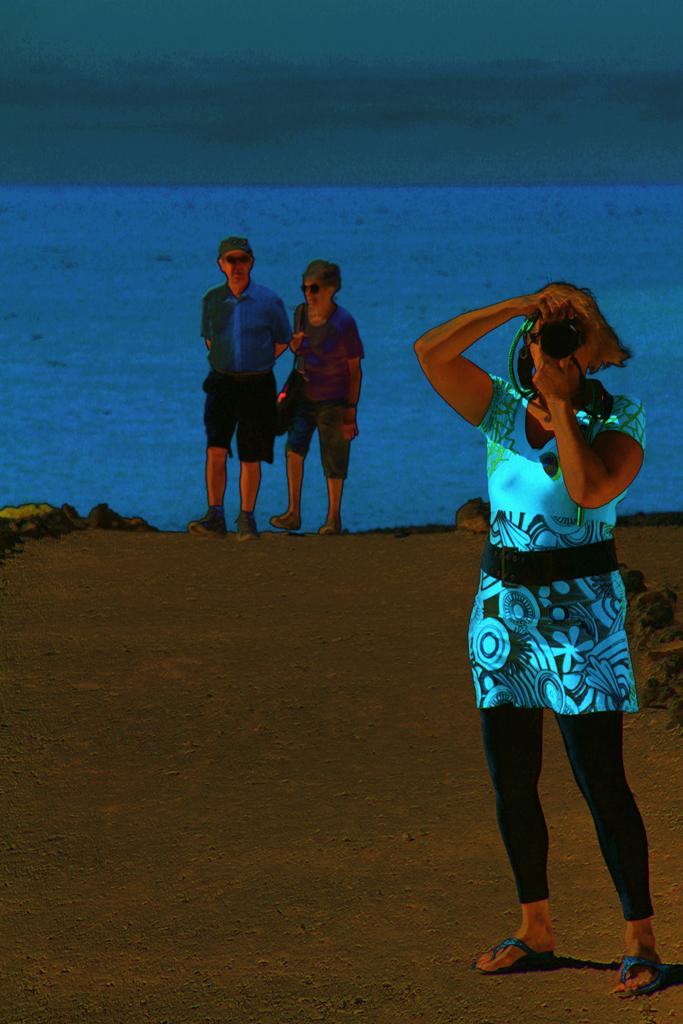What type of image is being described? The image is animated. Who is the main subject in the image? There is a woman in the image. What is the woman holding? The woman is holding a camera. Are there any other people in the image? Yes, there are two persons behind the woman. What natural element can be seen in the image? There is water visible in the image. How many cherries are on the table in the image? There are no cherries present in the image. What type of tool is being used by the woman in the image? The woman is holding a camera, not a tool like scissors. 